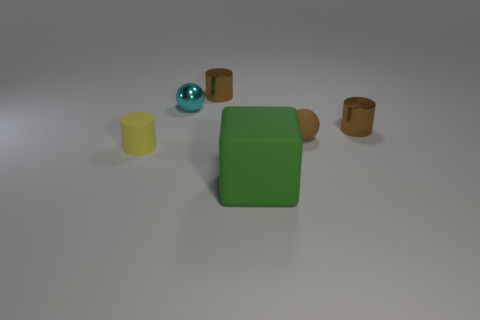Subtract all tiny brown cylinders. How many cylinders are left? 1 Subtract all blue blocks. How many brown cylinders are left? 2 Add 1 balls. How many objects exist? 7 Subtract all spheres. How many objects are left? 4 Subtract all blue cylinders. Subtract all cyan cubes. How many cylinders are left? 3 Add 4 yellow objects. How many yellow objects are left? 5 Add 3 tiny cylinders. How many tiny cylinders exist? 6 Subtract 0 green cylinders. How many objects are left? 6 Subtract all big purple shiny objects. Subtract all brown cylinders. How many objects are left? 4 